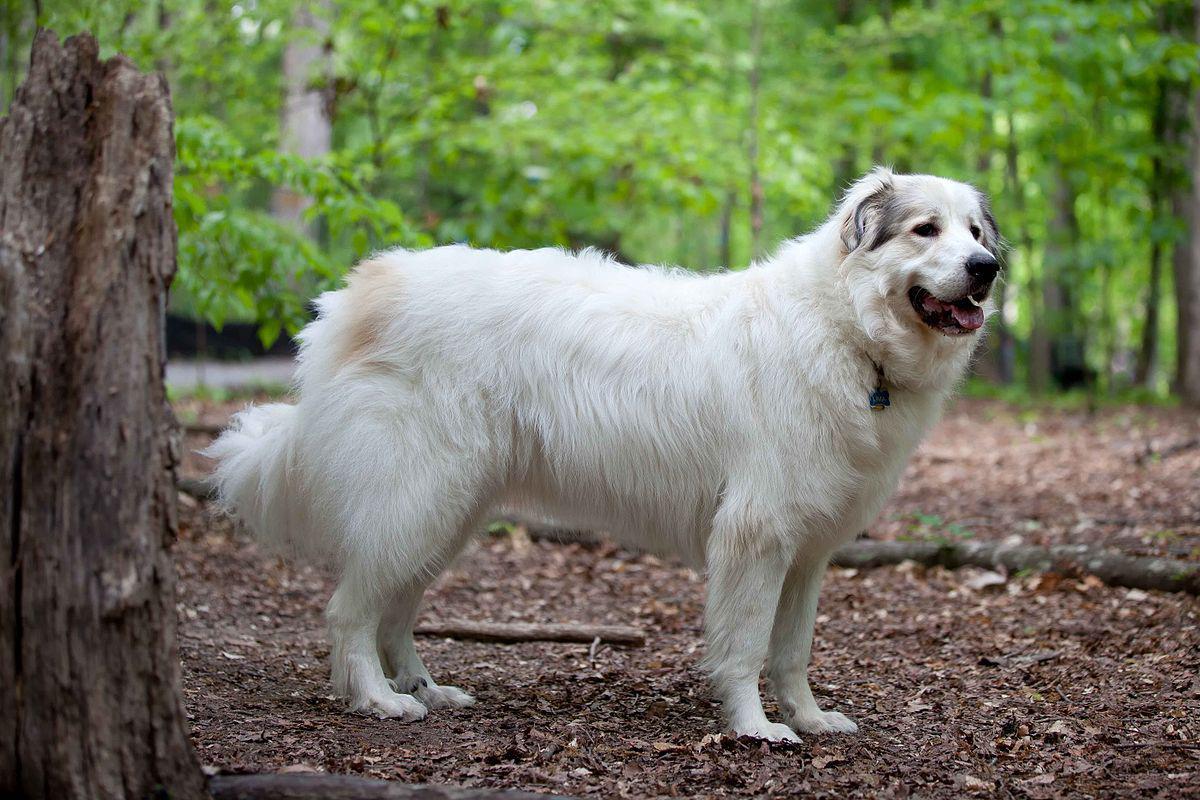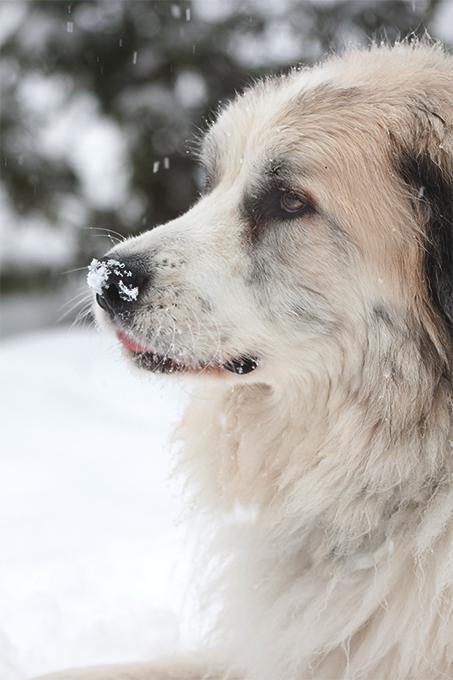The first image is the image on the left, the second image is the image on the right. Assess this claim about the two images: "The dog in the right image is facing right.". Correct or not? Answer yes or no. No. The first image is the image on the left, the second image is the image on the right. Examine the images to the left and right. Is the description "One image only shows the face and chest of a dog facing left." accurate? Answer yes or no. Yes. The first image is the image on the left, the second image is the image on the right. Considering the images on both sides, is "A dog is lying on all fours with its head up in the air." valid? Answer yes or no. No. The first image is the image on the left, the second image is the image on the right. For the images displayed, is the sentence "At least one of the dogs has a collar and tag clearly visible around it's neck." factually correct? Answer yes or no. Yes. The first image is the image on the left, the second image is the image on the right. Evaluate the accuracy of this statement regarding the images: "An image shows one big white dog, standing with its head and body turned rightwards.". Is it true? Answer yes or no. Yes. The first image is the image on the left, the second image is the image on the right. For the images shown, is this caption "An image shows a white dog standing still, its body in profile." true? Answer yes or no. Yes. The first image is the image on the left, the second image is the image on the right. Given the left and right images, does the statement "At least one dog is standing in the grass." hold true? Answer yes or no. No. 